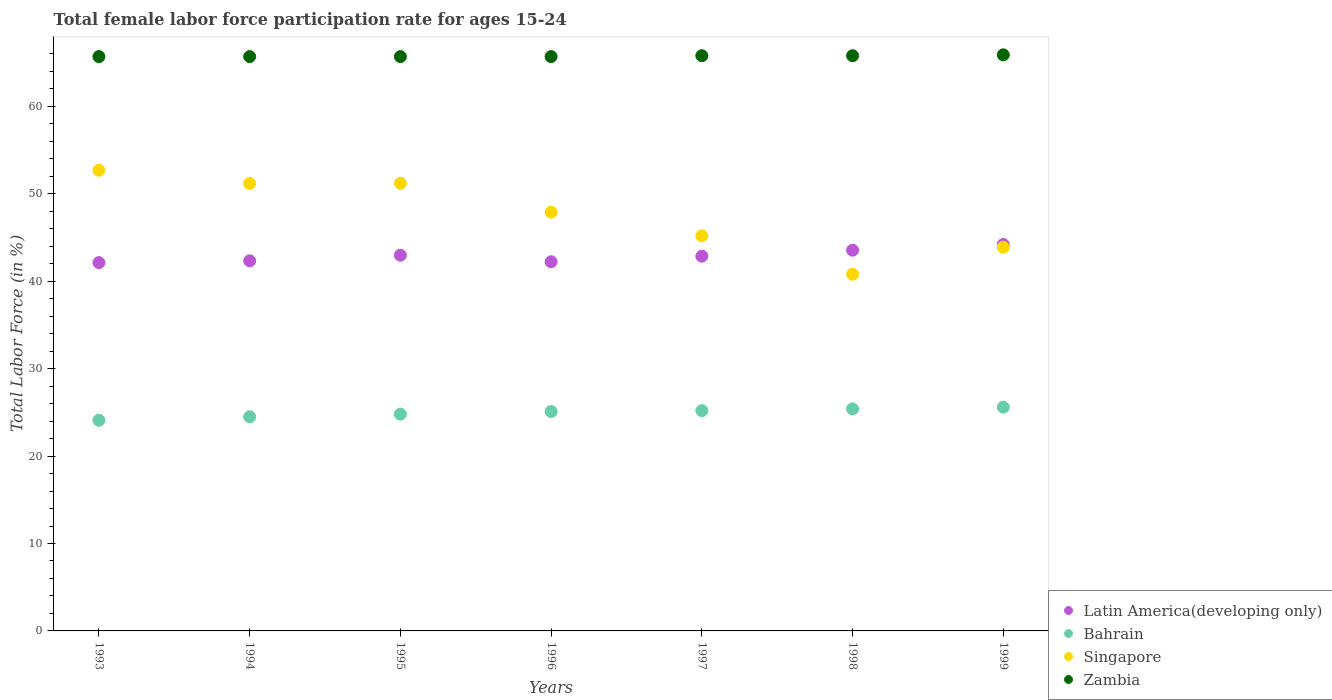What is the female labor force participation rate in Singapore in 1995?
Your answer should be very brief. 51.2. Across all years, what is the maximum female labor force participation rate in Zambia?
Ensure brevity in your answer.  65.9. Across all years, what is the minimum female labor force participation rate in Singapore?
Offer a very short reply. 40.8. What is the total female labor force participation rate in Latin America(developing only) in the graph?
Your response must be concise. 300.31. What is the difference between the female labor force participation rate in Bahrain in 1997 and that in 1999?
Ensure brevity in your answer.  -0.4. What is the difference between the female labor force participation rate in Zambia in 1998 and the female labor force participation rate in Bahrain in 1997?
Provide a short and direct response. 40.6. What is the average female labor force participation rate in Latin America(developing only) per year?
Provide a short and direct response. 42.9. In the year 1999, what is the difference between the female labor force participation rate in Singapore and female labor force participation rate in Latin America(developing only)?
Offer a very short reply. -0.31. In how many years, is the female labor force participation rate in Bahrain greater than 2 %?
Provide a succinct answer. 7. What is the ratio of the female labor force participation rate in Bahrain in 1993 to that in 1999?
Ensure brevity in your answer.  0.94. What is the difference between the highest and the second highest female labor force participation rate in Bahrain?
Your response must be concise. 0.2. What is the difference between the highest and the lowest female labor force participation rate in Latin America(developing only)?
Offer a very short reply. 2.07. Is the sum of the female labor force participation rate in Latin America(developing only) in 1996 and 1997 greater than the maximum female labor force participation rate in Bahrain across all years?
Your answer should be compact. Yes. Does the female labor force participation rate in Singapore monotonically increase over the years?
Your response must be concise. No. How many years are there in the graph?
Give a very brief answer. 7. Does the graph contain grids?
Offer a terse response. No. Where does the legend appear in the graph?
Ensure brevity in your answer.  Bottom right. What is the title of the graph?
Give a very brief answer. Total female labor force participation rate for ages 15-24. What is the label or title of the X-axis?
Give a very brief answer. Years. What is the label or title of the Y-axis?
Offer a terse response. Total Labor Force (in %). What is the Total Labor Force (in %) in Latin America(developing only) in 1993?
Make the answer very short. 42.13. What is the Total Labor Force (in %) in Bahrain in 1993?
Your answer should be very brief. 24.1. What is the Total Labor Force (in %) of Singapore in 1993?
Provide a succinct answer. 52.7. What is the Total Labor Force (in %) of Zambia in 1993?
Provide a short and direct response. 65.7. What is the Total Labor Force (in %) of Latin America(developing only) in 1994?
Your answer should be compact. 42.34. What is the Total Labor Force (in %) in Bahrain in 1994?
Make the answer very short. 24.5. What is the Total Labor Force (in %) in Singapore in 1994?
Offer a very short reply. 51.2. What is the Total Labor Force (in %) in Zambia in 1994?
Ensure brevity in your answer.  65.7. What is the Total Labor Force (in %) of Latin America(developing only) in 1995?
Ensure brevity in your answer.  42.98. What is the Total Labor Force (in %) in Bahrain in 1995?
Keep it short and to the point. 24.8. What is the Total Labor Force (in %) in Singapore in 1995?
Your answer should be compact. 51.2. What is the Total Labor Force (in %) in Zambia in 1995?
Offer a very short reply. 65.7. What is the Total Labor Force (in %) of Latin America(developing only) in 1996?
Make the answer very short. 42.23. What is the Total Labor Force (in %) of Bahrain in 1996?
Provide a succinct answer. 25.1. What is the Total Labor Force (in %) of Singapore in 1996?
Offer a very short reply. 47.9. What is the Total Labor Force (in %) of Zambia in 1996?
Your answer should be compact. 65.7. What is the Total Labor Force (in %) of Latin America(developing only) in 1997?
Ensure brevity in your answer.  42.87. What is the Total Labor Force (in %) in Bahrain in 1997?
Your answer should be very brief. 25.2. What is the Total Labor Force (in %) in Singapore in 1997?
Offer a very short reply. 45.2. What is the Total Labor Force (in %) in Zambia in 1997?
Provide a short and direct response. 65.8. What is the Total Labor Force (in %) of Latin America(developing only) in 1998?
Offer a very short reply. 43.55. What is the Total Labor Force (in %) of Bahrain in 1998?
Give a very brief answer. 25.4. What is the Total Labor Force (in %) in Singapore in 1998?
Make the answer very short. 40.8. What is the Total Labor Force (in %) in Zambia in 1998?
Your answer should be compact. 65.8. What is the Total Labor Force (in %) of Latin America(developing only) in 1999?
Make the answer very short. 44.21. What is the Total Labor Force (in %) in Bahrain in 1999?
Your answer should be compact. 25.6. What is the Total Labor Force (in %) of Singapore in 1999?
Make the answer very short. 43.9. What is the Total Labor Force (in %) in Zambia in 1999?
Your response must be concise. 65.9. Across all years, what is the maximum Total Labor Force (in %) in Latin America(developing only)?
Offer a very short reply. 44.21. Across all years, what is the maximum Total Labor Force (in %) of Bahrain?
Make the answer very short. 25.6. Across all years, what is the maximum Total Labor Force (in %) in Singapore?
Offer a very short reply. 52.7. Across all years, what is the maximum Total Labor Force (in %) in Zambia?
Your response must be concise. 65.9. Across all years, what is the minimum Total Labor Force (in %) in Latin America(developing only)?
Provide a succinct answer. 42.13. Across all years, what is the minimum Total Labor Force (in %) of Bahrain?
Provide a succinct answer. 24.1. Across all years, what is the minimum Total Labor Force (in %) in Singapore?
Your answer should be compact. 40.8. Across all years, what is the minimum Total Labor Force (in %) of Zambia?
Ensure brevity in your answer.  65.7. What is the total Total Labor Force (in %) in Latin America(developing only) in the graph?
Offer a very short reply. 300.31. What is the total Total Labor Force (in %) of Bahrain in the graph?
Your answer should be compact. 174.7. What is the total Total Labor Force (in %) in Singapore in the graph?
Your answer should be very brief. 332.9. What is the total Total Labor Force (in %) of Zambia in the graph?
Ensure brevity in your answer.  460.3. What is the difference between the Total Labor Force (in %) of Latin America(developing only) in 1993 and that in 1994?
Keep it short and to the point. -0.21. What is the difference between the Total Labor Force (in %) in Zambia in 1993 and that in 1994?
Your response must be concise. 0. What is the difference between the Total Labor Force (in %) of Latin America(developing only) in 1993 and that in 1995?
Make the answer very short. -0.85. What is the difference between the Total Labor Force (in %) of Bahrain in 1993 and that in 1995?
Keep it short and to the point. -0.7. What is the difference between the Total Labor Force (in %) of Singapore in 1993 and that in 1995?
Provide a succinct answer. 1.5. What is the difference between the Total Labor Force (in %) of Zambia in 1993 and that in 1995?
Ensure brevity in your answer.  0. What is the difference between the Total Labor Force (in %) of Latin America(developing only) in 1993 and that in 1996?
Offer a terse response. -0.1. What is the difference between the Total Labor Force (in %) in Bahrain in 1993 and that in 1996?
Give a very brief answer. -1. What is the difference between the Total Labor Force (in %) of Latin America(developing only) in 1993 and that in 1997?
Give a very brief answer. -0.74. What is the difference between the Total Labor Force (in %) in Bahrain in 1993 and that in 1997?
Your response must be concise. -1.1. What is the difference between the Total Labor Force (in %) in Zambia in 1993 and that in 1997?
Your response must be concise. -0.1. What is the difference between the Total Labor Force (in %) in Latin America(developing only) in 1993 and that in 1998?
Your answer should be compact. -1.42. What is the difference between the Total Labor Force (in %) of Bahrain in 1993 and that in 1998?
Your answer should be compact. -1.3. What is the difference between the Total Labor Force (in %) of Singapore in 1993 and that in 1998?
Provide a short and direct response. 11.9. What is the difference between the Total Labor Force (in %) of Zambia in 1993 and that in 1998?
Give a very brief answer. -0.1. What is the difference between the Total Labor Force (in %) of Latin America(developing only) in 1993 and that in 1999?
Provide a short and direct response. -2.07. What is the difference between the Total Labor Force (in %) of Latin America(developing only) in 1994 and that in 1995?
Your answer should be compact. -0.64. What is the difference between the Total Labor Force (in %) of Bahrain in 1994 and that in 1995?
Offer a very short reply. -0.3. What is the difference between the Total Labor Force (in %) of Singapore in 1994 and that in 1995?
Offer a terse response. 0. What is the difference between the Total Labor Force (in %) in Zambia in 1994 and that in 1995?
Give a very brief answer. 0. What is the difference between the Total Labor Force (in %) of Latin America(developing only) in 1994 and that in 1996?
Offer a very short reply. 0.11. What is the difference between the Total Labor Force (in %) in Latin America(developing only) in 1994 and that in 1997?
Your answer should be very brief. -0.53. What is the difference between the Total Labor Force (in %) of Bahrain in 1994 and that in 1997?
Your answer should be compact. -0.7. What is the difference between the Total Labor Force (in %) of Latin America(developing only) in 1994 and that in 1998?
Offer a very short reply. -1.21. What is the difference between the Total Labor Force (in %) of Latin America(developing only) in 1994 and that in 1999?
Your response must be concise. -1.87. What is the difference between the Total Labor Force (in %) in Singapore in 1994 and that in 1999?
Offer a terse response. 7.3. What is the difference between the Total Labor Force (in %) of Latin America(developing only) in 1995 and that in 1996?
Your answer should be compact. 0.75. What is the difference between the Total Labor Force (in %) of Singapore in 1995 and that in 1996?
Ensure brevity in your answer.  3.3. What is the difference between the Total Labor Force (in %) in Zambia in 1995 and that in 1996?
Give a very brief answer. 0. What is the difference between the Total Labor Force (in %) of Latin America(developing only) in 1995 and that in 1997?
Offer a terse response. 0.11. What is the difference between the Total Labor Force (in %) of Bahrain in 1995 and that in 1997?
Offer a terse response. -0.4. What is the difference between the Total Labor Force (in %) in Latin America(developing only) in 1995 and that in 1998?
Make the answer very short. -0.57. What is the difference between the Total Labor Force (in %) in Bahrain in 1995 and that in 1998?
Your answer should be very brief. -0.6. What is the difference between the Total Labor Force (in %) of Zambia in 1995 and that in 1998?
Provide a short and direct response. -0.1. What is the difference between the Total Labor Force (in %) in Latin America(developing only) in 1995 and that in 1999?
Make the answer very short. -1.23. What is the difference between the Total Labor Force (in %) in Singapore in 1995 and that in 1999?
Ensure brevity in your answer.  7.3. What is the difference between the Total Labor Force (in %) of Latin America(developing only) in 1996 and that in 1997?
Provide a succinct answer. -0.64. What is the difference between the Total Labor Force (in %) in Singapore in 1996 and that in 1997?
Give a very brief answer. 2.7. What is the difference between the Total Labor Force (in %) in Latin America(developing only) in 1996 and that in 1998?
Offer a terse response. -1.32. What is the difference between the Total Labor Force (in %) of Bahrain in 1996 and that in 1998?
Keep it short and to the point. -0.3. What is the difference between the Total Labor Force (in %) in Singapore in 1996 and that in 1998?
Offer a very short reply. 7.1. What is the difference between the Total Labor Force (in %) of Latin America(developing only) in 1996 and that in 1999?
Your answer should be compact. -1.97. What is the difference between the Total Labor Force (in %) of Latin America(developing only) in 1997 and that in 1998?
Provide a succinct answer. -0.68. What is the difference between the Total Labor Force (in %) in Singapore in 1997 and that in 1998?
Your answer should be very brief. 4.4. What is the difference between the Total Labor Force (in %) of Latin America(developing only) in 1997 and that in 1999?
Provide a succinct answer. -1.34. What is the difference between the Total Labor Force (in %) of Bahrain in 1997 and that in 1999?
Keep it short and to the point. -0.4. What is the difference between the Total Labor Force (in %) of Singapore in 1997 and that in 1999?
Your answer should be very brief. 1.3. What is the difference between the Total Labor Force (in %) of Zambia in 1997 and that in 1999?
Make the answer very short. -0.1. What is the difference between the Total Labor Force (in %) of Latin America(developing only) in 1998 and that in 1999?
Make the answer very short. -0.65. What is the difference between the Total Labor Force (in %) of Latin America(developing only) in 1993 and the Total Labor Force (in %) of Bahrain in 1994?
Offer a terse response. 17.63. What is the difference between the Total Labor Force (in %) of Latin America(developing only) in 1993 and the Total Labor Force (in %) of Singapore in 1994?
Offer a terse response. -9.07. What is the difference between the Total Labor Force (in %) in Latin America(developing only) in 1993 and the Total Labor Force (in %) in Zambia in 1994?
Provide a succinct answer. -23.57. What is the difference between the Total Labor Force (in %) of Bahrain in 1993 and the Total Labor Force (in %) of Singapore in 1994?
Offer a very short reply. -27.1. What is the difference between the Total Labor Force (in %) in Bahrain in 1993 and the Total Labor Force (in %) in Zambia in 1994?
Offer a terse response. -41.6. What is the difference between the Total Labor Force (in %) in Singapore in 1993 and the Total Labor Force (in %) in Zambia in 1994?
Offer a very short reply. -13. What is the difference between the Total Labor Force (in %) in Latin America(developing only) in 1993 and the Total Labor Force (in %) in Bahrain in 1995?
Ensure brevity in your answer.  17.33. What is the difference between the Total Labor Force (in %) in Latin America(developing only) in 1993 and the Total Labor Force (in %) in Singapore in 1995?
Your answer should be very brief. -9.07. What is the difference between the Total Labor Force (in %) in Latin America(developing only) in 1993 and the Total Labor Force (in %) in Zambia in 1995?
Keep it short and to the point. -23.57. What is the difference between the Total Labor Force (in %) of Bahrain in 1993 and the Total Labor Force (in %) of Singapore in 1995?
Your answer should be very brief. -27.1. What is the difference between the Total Labor Force (in %) in Bahrain in 1993 and the Total Labor Force (in %) in Zambia in 1995?
Keep it short and to the point. -41.6. What is the difference between the Total Labor Force (in %) in Singapore in 1993 and the Total Labor Force (in %) in Zambia in 1995?
Your answer should be very brief. -13. What is the difference between the Total Labor Force (in %) of Latin America(developing only) in 1993 and the Total Labor Force (in %) of Bahrain in 1996?
Your answer should be compact. 17.03. What is the difference between the Total Labor Force (in %) in Latin America(developing only) in 1993 and the Total Labor Force (in %) in Singapore in 1996?
Give a very brief answer. -5.77. What is the difference between the Total Labor Force (in %) in Latin America(developing only) in 1993 and the Total Labor Force (in %) in Zambia in 1996?
Offer a terse response. -23.57. What is the difference between the Total Labor Force (in %) of Bahrain in 1993 and the Total Labor Force (in %) of Singapore in 1996?
Make the answer very short. -23.8. What is the difference between the Total Labor Force (in %) of Bahrain in 1993 and the Total Labor Force (in %) of Zambia in 1996?
Keep it short and to the point. -41.6. What is the difference between the Total Labor Force (in %) of Latin America(developing only) in 1993 and the Total Labor Force (in %) of Bahrain in 1997?
Provide a short and direct response. 16.93. What is the difference between the Total Labor Force (in %) of Latin America(developing only) in 1993 and the Total Labor Force (in %) of Singapore in 1997?
Offer a very short reply. -3.07. What is the difference between the Total Labor Force (in %) of Latin America(developing only) in 1993 and the Total Labor Force (in %) of Zambia in 1997?
Your answer should be compact. -23.67. What is the difference between the Total Labor Force (in %) of Bahrain in 1993 and the Total Labor Force (in %) of Singapore in 1997?
Keep it short and to the point. -21.1. What is the difference between the Total Labor Force (in %) of Bahrain in 1993 and the Total Labor Force (in %) of Zambia in 1997?
Provide a succinct answer. -41.7. What is the difference between the Total Labor Force (in %) of Singapore in 1993 and the Total Labor Force (in %) of Zambia in 1997?
Offer a very short reply. -13.1. What is the difference between the Total Labor Force (in %) in Latin America(developing only) in 1993 and the Total Labor Force (in %) in Bahrain in 1998?
Keep it short and to the point. 16.73. What is the difference between the Total Labor Force (in %) of Latin America(developing only) in 1993 and the Total Labor Force (in %) of Singapore in 1998?
Provide a short and direct response. 1.33. What is the difference between the Total Labor Force (in %) in Latin America(developing only) in 1993 and the Total Labor Force (in %) in Zambia in 1998?
Offer a very short reply. -23.67. What is the difference between the Total Labor Force (in %) of Bahrain in 1993 and the Total Labor Force (in %) of Singapore in 1998?
Keep it short and to the point. -16.7. What is the difference between the Total Labor Force (in %) of Bahrain in 1993 and the Total Labor Force (in %) of Zambia in 1998?
Provide a succinct answer. -41.7. What is the difference between the Total Labor Force (in %) in Latin America(developing only) in 1993 and the Total Labor Force (in %) in Bahrain in 1999?
Ensure brevity in your answer.  16.53. What is the difference between the Total Labor Force (in %) in Latin America(developing only) in 1993 and the Total Labor Force (in %) in Singapore in 1999?
Give a very brief answer. -1.77. What is the difference between the Total Labor Force (in %) of Latin America(developing only) in 1993 and the Total Labor Force (in %) of Zambia in 1999?
Provide a short and direct response. -23.77. What is the difference between the Total Labor Force (in %) of Bahrain in 1993 and the Total Labor Force (in %) of Singapore in 1999?
Your answer should be compact. -19.8. What is the difference between the Total Labor Force (in %) in Bahrain in 1993 and the Total Labor Force (in %) in Zambia in 1999?
Your response must be concise. -41.8. What is the difference between the Total Labor Force (in %) of Latin America(developing only) in 1994 and the Total Labor Force (in %) of Bahrain in 1995?
Your answer should be compact. 17.54. What is the difference between the Total Labor Force (in %) of Latin America(developing only) in 1994 and the Total Labor Force (in %) of Singapore in 1995?
Keep it short and to the point. -8.86. What is the difference between the Total Labor Force (in %) of Latin America(developing only) in 1994 and the Total Labor Force (in %) of Zambia in 1995?
Your response must be concise. -23.36. What is the difference between the Total Labor Force (in %) of Bahrain in 1994 and the Total Labor Force (in %) of Singapore in 1995?
Offer a terse response. -26.7. What is the difference between the Total Labor Force (in %) in Bahrain in 1994 and the Total Labor Force (in %) in Zambia in 1995?
Provide a short and direct response. -41.2. What is the difference between the Total Labor Force (in %) in Latin America(developing only) in 1994 and the Total Labor Force (in %) in Bahrain in 1996?
Ensure brevity in your answer.  17.24. What is the difference between the Total Labor Force (in %) of Latin America(developing only) in 1994 and the Total Labor Force (in %) of Singapore in 1996?
Your response must be concise. -5.56. What is the difference between the Total Labor Force (in %) in Latin America(developing only) in 1994 and the Total Labor Force (in %) in Zambia in 1996?
Ensure brevity in your answer.  -23.36. What is the difference between the Total Labor Force (in %) in Bahrain in 1994 and the Total Labor Force (in %) in Singapore in 1996?
Ensure brevity in your answer.  -23.4. What is the difference between the Total Labor Force (in %) in Bahrain in 1994 and the Total Labor Force (in %) in Zambia in 1996?
Give a very brief answer. -41.2. What is the difference between the Total Labor Force (in %) in Latin America(developing only) in 1994 and the Total Labor Force (in %) in Bahrain in 1997?
Ensure brevity in your answer.  17.14. What is the difference between the Total Labor Force (in %) of Latin America(developing only) in 1994 and the Total Labor Force (in %) of Singapore in 1997?
Provide a succinct answer. -2.86. What is the difference between the Total Labor Force (in %) in Latin America(developing only) in 1994 and the Total Labor Force (in %) in Zambia in 1997?
Offer a terse response. -23.46. What is the difference between the Total Labor Force (in %) in Bahrain in 1994 and the Total Labor Force (in %) in Singapore in 1997?
Offer a very short reply. -20.7. What is the difference between the Total Labor Force (in %) of Bahrain in 1994 and the Total Labor Force (in %) of Zambia in 1997?
Your answer should be very brief. -41.3. What is the difference between the Total Labor Force (in %) in Singapore in 1994 and the Total Labor Force (in %) in Zambia in 1997?
Provide a succinct answer. -14.6. What is the difference between the Total Labor Force (in %) of Latin America(developing only) in 1994 and the Total Labor Force (in %) of Bahrain in 1998?
Your response must be concise. 16.94. What is the difference between the Total Labor Force (in %) of Latin America(developing only) in 1994 and the Total Labor Force (in %) of Singapore in 1998?
Ensure brevity in your answer.  1.54. What is the difference between the Total Labor Force (in %) in Latin America(developing only) in 1994 and the Total Labor Force (in %) in Zambia in 1998?
Your answer should be compact. -23.46. What is the difference between the Total Labor Force (in %) in Bahrain in 1994 and the Total Labor Force (in %) in Singapore in 1998?
Keep it short and to the point. -16.3. What is the difference between the Total Labor Force (in %) of Bahrain in 1994 and the Total Labor Force (in %) of Zambia in 1998?
Give a very brief answer. -41.3. What is the difference between the Total Labor Force (in %) in Singapore in 1994 and the Total Labor Force (in %) in Zambia in 1998?
Offer a terse response. -14.6. What is the difference between the Total Labor Force (in %) of Latin America(developing only) in 1994 and the Total Labor Force (in %) of Bahrain in 1999?
Your answer should be very brief. 16.74. What is the difference between the Total Labor Force (in %) of Latin America(developing only) in 1994 and the Total Labor Force (in %) of Singapore in 1999?
Offer a very short reply. -1.56. What is the difference between the Total Labor Force (in %) of Latin America(developing only) in 1994 and the Total Labor Force (in %) of Zambia in 1999?
Offer a very short reply. -23.56. What is the difference between the Total Labor Force (in %) of Bahrain in 1994 and the Total Labor Force (in %) of Singapore in 1999?
Offer a terse response. -19.4. What is the difference between the Total Labor Force (in %) of Bahrain in 1994 and the Total Labor Force (in %) of Zambia in 1999?
Make the answer very short. -41.4. What is the difference between the Total Labor Force (in %) of Singapore in 1994 and the Total Labor Force (in %) of Zambia in 1999?
Provide a succinct answer. -14.7. What is the difference between the Total Labor Force (in %) of Latin America(developing only) in 1995 and the Total Labor Force (in %) of Bahrain in 1996?
Provide a succinct answer. 17.88. What is the difference between the Total Labor Force (in %) of Latin America(developing only) in 1995 and the Total Labor Force (in %) of Singapore in 1996?
Offer a terse response. -4.92. What is the difference between the Total Labor Force (in %) in Latin America(developing only) in 1995 and the Total Labor Force (in %) in Zambia in 1996?
Ensure brevity in your answer.  -22.72. What is the difference between the Total Labor Force (in %) of Bahrain in 1995 and the Total Labor Force (in %) of Singapore in 1996?
Your answer should be compact. -23.1. What is the difference between the Total Labor Force (in %) in Bahrain in 1995 and the Total Labor Force (in %) in Zambia in 1996?
Give a very brief answer. -40.9. What is the difference between the Total Labor Force (in %) of Singapore in 1995 and the Total Labor Force (in %) of Zambia in 1996?
Offer a very short reply. -14.5. What is the difference between the Total Labor Force (in %) in Latin America(developing only) in 1995 and the Total Labor Force (in %) in Bahrain in 1997?
Your response must be concise. 17.78. What is the difference between the Total Labor Force (in %) of Latin America(developing only) in 1995 and the Total Labor Force (in %) of Singapore in 1997?
Keep it short and to the point. -2.22. What is the difference between the Total Labor Force (in %) in Latin America(developing only) in 1995 and the Total Labor Force (in %) in Zambia in 1997?
Your answer should be very brief. -22.82. What is the difference between the Total Labor Force (in %) in Bahrain in 1995 and the Total Labor Force (in %) in Singapore in 1997?
Ensure brevity in your answer.  -20.4. What is the difference between the Total Labor Force (in %) of Bahrain in 1995 and the Total Labor Force (in %) of Zambia in 1997?
Offer a very short reply. -41. What is the difference between the Total Labor Force (in %) in Singapore in 1995 and the Total Labor Force (in %) in Zambia in 1997?
Your answer should be compact. -14.6. What is the difference between the Total Labor Force (in %) in Latin America(developing only) in 1995 and the Total Labor Force (in %) in Bahrain in 1998?
Keep it short and to the point. 17.58. What is the difference between the Total Labor Force (in %) of Latin America(developing only) in 1995 and the Total Labor Force (in %) of Singapore in 1998?
Give a very brief answer. 2.18. What is the difference between the Total Labor Force (in %) of Latin America(developing only) in 1995 and the Total Labor Force (in %) of Zambia in 1998?
Make the answer very short. -22.82. What is the difference between the Total Labor Force (in %) of Bahrain in 1995 and the Total Labor Force (in %) of Singapore in 1998?
Provide a succinct answer. -16. What is the difference between the Total Labor Force (in %) in Bahrain in 1995 and the Total Labor Force (in %) in Zambia in 1998?
Give a very brief answer. -41. What is the difference between the Total Labor Force (in %) in Singapore in 1995 and the Total Labor Force (in %) in Zambia in 1998?
Your answer should be very brief. -14.6. What is the difference between the Total Labor Force (in %) of Latin America(developing only) in 1995 and the Total Labor Force (in %) of Bahrain in 1999?
Keep it short and to the point. 17.38. What is the difference between the Total Labor Force (in %) in Latin America(developing only) in 1995 and the Total Labor Force (in %) in Singapore in 1999?
Offer a terse response. -0.92. What is the difference between the Total Labor Force (in %) in Latin America(developing only) in 1995 and the Total Labor Force (in %) in Zambia in 1999?
Provide a succinct answer. -22.92. What is the difference between the Total Labor Force (in %) in Bahrain in 1995 and the Total Labor Force (in %) in Singapore in 1999?
Give a very brief answer. -19.1. What is the difference between the Total Labor Force (in %) of Bahrain in 1995 and the Total Labor Force (in %) of Zambia in 1999?
Your answer should be compact. -41.1. What is the difference between the Total Labor Force (in %) of Singapore in 1995 and the Total Labor Force (in %) of Zambia in 1999?
Ensure brevity in your answer.  -14.7. What is the difference between the Total Labor Force (in %) of Latin America(developing only) in 1996 and the Total Labor Force (in %) of Bahrain in 1997?
Keep it short and to the point. 17.03. What is the difference between the Total Labor Force (in %) of Latin America(developing only) in 1996 and the Total Labor Force (in %) of Singapore in 1997?
Provide a succinct answer. -2.97. What is the difference between the Total Labor Force (in %) in Latin America(developing only) in 1996 and the Total Labor Force (in %) in Zambia in 1997?
Provide a succinct answer. -23.57. What is the difference between the Total Labor Force (in %) in Bahrain in 1996 and the Total Labor Force (in %) in Singapore in 1997?
Provide a short and direct response. -20.1. What is the difference between the Total Labor Force (in %) of Bahrain in 1996 and the Total Labor Force (in %) of Zambia in 1997?
Your answer should be very brief. -40.7. What is the difference between the Total Labor Force (in %) in Singapore in 1996 and the Total Labor Force (in %) in Zambia in 1997?
Ensure brevity in your answer.  -17.9. What is the difference between the Total Labor Force (in %) of Latin America(developing only) in 1996 and the Total Labor Force (in %) of Bahrain in 1998?
Offer a terse response. 16.83. What is the difference between the Total Labor Force (in %) of Latin America(developing only) in 1996 and the Total Labor Force (in %) of Singapore in 1998?
Provide a succinct answer. 1.43. What is the difference between the Total Labor Force (in %) in Latin America(developing only) in 1996 and the Total Labor Force (in %) in Zambia in 1998?
Make the answer very short. -23.57. What is the difference between the Total Labor Force (in %) of Bahrain in 1996 and the Total Labor Force (in %) of Singapore in 1998?
Your response must be concise. -15.7. What is the difference between the Total Labor Force (in %) of Bahrain in 1996 and the Total Labor Force (in %) of Zambia in 1998?
Keep it short and to the point. -40.7. What is the difference between the Total Labor Force (in %) in Singapore in 1996 and the Total Labor Force (in %) in Zambia in 1998?
Provide a succinct answer. -17.9. What is the difference between the Total Labor Force (in %) of Latin America(developing only) in 1996 and the Total Labor Force (in %) of Bahrain in 1999?
Ensure brevity in your answer.  16.63. What is the difference between the Total Labor Force (in %) of Latin America(developing only) in 1996 and the Total Labor Force (in %) of Singapore in 1999?
Offer a terse response. -1.67. What is the difference between the Total Labor Force (in %) of Latin America(developing only) in 1996 and the Total Labor Force (in %) of Zambia in 1999?
Offer a terse response. -23.67. What is the difference between the Total Labor Force (in %) in Bahrain in 1996 and the Total Labor Force (in %) in Singapore in 1999?
Provide a short and direct response. -18.8. What is the difference between the Total Labor Force (in %) in Bahrain in 1996 and the Total Labor Force (in %) in Zambia in 1999?
Give a very brief answer. -40.8. What is the difference between the Total Labor Force (in %) of Latin America(developing only) in 1997 and the Total Labor Force (in %) of Bahrain in 1998?
Provide a succinct answer. 17.47. What is the difference between the Total Labor Force (in %) in Latin America(developing only) in 1997 and the Total Labor Force (in %) in Singapore in 1998?
Your answer should be very brief. 2.07. What is the difference between the Total Labor Force (in %) of Latin America(developing only) in 1997 and the Total Labor Force (in %) of Zambia in 1998?
Make the answer very short. -22.93. What is the difference between the Total Labor Force (in %) of Bahrain in 1997 and the Total Labor Force (in %) of Singapore in 1998?
Your answer should be compact. -15.6. What is the difference between the Total Labor Force (in %) in Bahrain in 1997 and the Total Labor Force (in %) in Zambia in 1998?
Offer a terse response. -40.6. What is the difference between the Total Labor Force (in %) of Singapore in 1997 and the Total Labor Force (in %) of Zambia in 1998?
Offer a very short reply. -20.6. What is the difference between the Total Labor Force (in %) of Latin America(developing only) in 1997 and the Total Labor Force (in %) of Bahrain in 1999?
Offer a very short reply. 17.27. What is the difference between the Total Labor Force (in %) in Latin America(developing only) in 1997 and the Total Labor Force (in %) in Singapore in 1999?
Your response must be concise. -1.03. What is the difference between the Total Labor Force (in %) in Latin America(developing only) in 1997 and the Total Labor Force (in %) in Zambia in 1999?
Offer a terse response. -23.03. What is the difference between the Total Labor Force (in %) in Bahrain in 1997 and the Total Labor Force (in %) in Singapore in 1999?
Make the answer very short. -18.7. What is the difference between the Total Labor Force (in %) in Bahrain in 1997 and the Total Labor Force (in %) in Zambia in 1999?
Make the answer very short. -40.7. What is the difference between the Total Labor Force (in %) of Singapore in 1997 and the Total Labor Force (in %) of Zambia in 1999?
Offer a very short reply. -20.7. What is the difference between the Total Labor Force (in %) in Latin America(developing only) in 1998 and the Total Labor Force (in %) in Bahrain in 1999?
Keep it short and to the point. 17.95. What is the difference between the Total Labor Force (in %) in Latin America(developing only) in 1998 and the Total Labor Force (in %) in Singapore in 1999?
Your answer should be compact. -0.35. What is the difference between the Total Labor Force (in %) in Latin America(developing only) in 1998 and the Total Labor Force (in %) in Zambia in 1999?
Your answer should be compact. -22.35. What is the difference between the Total Labor Force (in %) in Bahrain in 1998 and the Total Labor Force (in %) in Singapore in 1999?
Offer a terse response. -18.5. What is the difference between the Total Labor Force (in %) in Bahrain in 1998 and the Total Labor Force (in %) in Zambia in 1999?
Ensure brevity in your answer.  -40.5. What is the difference between the Total Labor Force (in %) in Singapore in 1998 and the Total Labor Force (in %) in Zambia in 1999?
Provide a short and direct response. -25.1. What is the average Total Labor Force (in %) of Latin America(developing only) per year?
Your answer should be compact. 42.9. What is the average Total Labor Force (in %) in Bahrain per year?
Make the answer very short. 24.96. What is the average Total Labor Force (in %) in Singapore per year?
Your answer should be compact. 47.56. What is the average Total Labor Force (in %) of Zambia per year?
Provide a short and direct response. 65.76. In the year 1993, what is the difference between the Total Labor Force (in %) of Latin America(developing only) and Total Labor Force (in %) of Bahrain?
Keep it short and to the point. 18.03. In the year 1993, what is the difference between the Total Labor Force (in %) of Latin America(developing only) and Total Labor Force (in %) of Singapore?
Offer a very short reply. -10.57. In the year 1993, what is the difference between the Total Labor Force (in %) in Latin America(developing only) and Total Labor Force (in %) in Zambia?
Give a very brief answer. -23.57. In the year 1993, what is the difference between the Total Labor Force (in %) in Bahrain and Total Labor Force (in %) in Singapore?
Provide a succinct answer. -28.6. In the year 1993, what is the difference between the Total Labor Force (in %) of Bahrain and Total Labor Force (in %) of Zambia?
Keep it short and to the point. -41.6. In the year 1993, what is the difference between the Total Labor Force (in %) of Singapore and Total Labor Force (in %) of Zambia?
Your response must be concise. -13. In the year 1994, what is the difference between the Total Labor Force (in %) of Latin America(developing only) and Total Labor Force (in %) of Bahrain?
Offer a very short reply. 17.84. In the year 1994, what is the difference between the Total Labor Force (in %) in Latin America(developing only) and Total Labor Force (in %) in Singapore?
Your response must be concise. -8.86. In the year 1994, what is the difference between the Total Labor Force (in %) in Latin America(developing only) and Total Labor Force (in %) in Zambia?
Make the answer very short. -23.36. In the year 1994, what is the difference between the Total Labor Force (in %) of Bahrain and Total Labor Force (in %) of Singapore?
Your answer should be compact. -26.7. In the year 1994, what is the difference between the Total Labor Force (in %) of Bahrain and Total Labor Force (in %) of Zambia?
Ensure brevity in your answer.  -41.2. In the year 1995, what is the difference between the Total Labor Force (in %) in Latin America(developing only) and Total Labor Force (in %) in Bahrain?
Make the answer very short. 18.18. In the year 1995, what is the difference between the Total Labor Force (in %) in Latin America(developing only) and Total Labor Force (in %) in Singapore?
Your response must be concise. -8.22. In the year 1995, what is the difference between the Total Labor Force (in %) of Latin America(developing only) and Total Labor Force (in %) of Zambia?
Your answer should be compact. -22.72. In the year 1995, what is the difference between the Total Labor Force (in %) of Bahrain and Total Labor Force (in %) of Singapore?
Ensure brevity in your answer.  -26.4. In the year 1995, what is the difference between the Total Labor Force (in %) in Bahrain and Total Labor Force (in %) in Zambia?
Offer a terse response. -40.9. In the year 1996, what is the difference between the Total Labor Force (in %) in Latin America(developing only) and Total Labor Force (in %) in Bahrain?
Your response must be concise. 17.13. In the year 1996, what is the difference between the Total Labor Force (in %) of Latin America(developing only) and Total Labor Force (in %) of Singapore?
Offer a very short reply. -5.67. In the year 1996, what is the difference between the Total Labor Force (in %) of Latin America(developing only) and Total Labor Force (in %) of Zambia?
Provide a short and direct response. -23.47. In the year 1996, what is the difference between the Total Labor Force (in %) of Bahrain and Total Labor Force (in %) of Singapore?
Make the answer very short. -22.8. In the year 1996, what is the difference between the Total Labor Force (in %) in Bahrain and Total Labor Force (in %) in Zambia?
Offer a terse response. -40.6. In the year 1996, what is the difference between the Total Labor Force (in %) of Singapore and Total Labor Force (in %) of Zambia?
Make the answer very short. -17.8. In the year 1997, what is the difference between the Total Labor Force (in %) in Latin America(developing only) and Total Labor Force (in %) in Bahrain?
Offer a very short reply. 17.67. In the year 1997, what is the difference between the Total Labor Force (in %) of Latin America(developing only) and Total Labor Force (in %) of Singapore?
Ensure brevity in your answer.  -2.33. In the year 1997, what is the difference between the Total Labor Force (in %) of Latin America(developing only) and Total Labor Force (in %) of Zambia?
Make the answer very short. -22.93. In the year 1997, what is the difference between the Total Labor Force (in %) of Bahrain and Total Labor Force (in %) of Singapore?
Keep it short and to the point. -20. In the year 1997, what is the difference between the Total Labor Force (in %) in Bahrain and Total Labor Force (in %) in Zambia?
Offer a terse response. -40.6. In the year 1997, what is the difference between the Total Labor Force (in %) of Singapore and Total Labor Force (in %) of Zambia?
Your answer should be compact. -20.6. In the year 1998, what is the difference between the Total Labor Force (in %) in Latin America(developing only) and Total Labor Force (in %) in Bahrain?
Keep it short and to the point. 18.15. In the year 1998, what is the difference between the Total Labor Force (in %) in Latin America(developing only) and Total Labor Force (in %) in Singapore?
Your answer should be very brief. 2.75. In the year 1998, what is the difference between the Total Labor Force (in %) of Latin America(developing only) and Total Labor Force (in %) of Zambia?
Offer a terse response. -22.25. In the year 1998, what is the difference between the Total Labor Force (in %) in Bahrain and Total Labor Force (in %) in Singapore?
Provide a short and direct response. -15.4. In the year 1998, what is the difference between the Total Labor Force (in %) of Bahrain and Total Labor Force (in %) of Zambia?
Offer a very short reply. -40.4. In the year 1998, what is the difference between the Total Labor Force (in %) in Singapore and Total Labor Force (in %) in Zambia?
Your response must be concise. -25. In the year 1999, what is the difference between the Total Labor Force (in %) of Latin America(developing only) and Total Labor Force (in %) of Bahrain?
Make the answer very short. 18.61. In the year 1999, what is the difference between the Total Labor Force (in %) of Latin America(developing only) and Total Labor Force (in %) of Singapore?
Provide a succinct answer. 0.31. In the year 1999, what is the difference between the Total Labor Force (in %) in Latin America(developing only) and Total Labor Force (in %) in Zambia?
Make the answer very short. -21.69. In the year 1999, what is the difference between the Total Labor Force (in %) of Bahrain and Total Labor Force (in %) of Singapore?
Ensure brevity in your answer.  -18.3. In the year 1999, what is the difference between the Total Labor Force (in %) of Bahrain and Total Labor Force (in %) of Zambia?
Your response must be concise. -40.3. What is the ratio of the Total Labor Force (in %) of Bahrain in 1993 to that in 1994?
Offer a terse response. 0.98. What is the ratio of the Total Labor Force (in %) of Singapore in 1993 to that in 1994?
Provide a succinct answer. 1.03. What is the ratio of the Total Labor Force (in %) in Zambia in 1993 to that in 1994?
Offer a very short reply. 1. What is the ratio of the Total Labor Force (in %) in Latin America(developing only) in 1993 to that in 1995?
Keep it short and to the point. 0.98. What is the ratio of the Total Labor Force (in %) of Bahrain in 1993 to that in 1995?
Offer a very short reply. 0.97. What is the ratio of the Total Labor Force (in %) in Singapore in 1993 to that in 1995?
Keep it short and to the point. 1.03. What is the ratio of the Total Labor Force (in %) in Zambia in 1993 to that in 1995?
Your answer should be compact. 1. What is the ratio of the Total Labor Force (in %) in Latin America(developing only) in 1993 to that in 1996?
Give a very brief answer. 1. What is the ratio of the Total Labor Force (in %) in Bahrain in 1993 to that in 1996?
Your answer should be very brief. 0.96. What is the ratio of the Total Labor Force (in %) in Singapore in 1993 to that in 1996?
Give a very brief answer. 1.1. What is the ratio of the Total Labor Force (in %) in Zambia in 1993 to that in 1996?
Make the answer very short. 1. What is the ratio of the Total Labor Force (in %) in Latin America(developing only) in 1993 to that in 1997?
Make the answer very short. 0.98. What is the ratio of the Total Labor Force (in %) of Bahrain in 1993 to that in 1997?
Your answer should be very brief. 0.96. What is the ratio of the Total Labor Force (in %) in Singapore in 1993 to that in 1997?
Give a very brief answer. 1.17. What is the ratio of the Total Labor Force (in %) of Latin America(developing only) in 1993 to that in 1998?
Provide a succinct answer. 0.97. What is the ratio of the Total Labor Force (in %) of Bahrain in 1993 to that in 1998?
Your answer should be compact. 0.95. What is the ratio of the Total Labor Force (in %) in Singapore in 1993 to that in 1998?
Your answer should be compact. 1.29. What is the ratio of the Total Labor Force (in %) of Zambia in 1993 to that in 1998?
Your response must be concise. 1. What is the ratio of the Total Labor Force (in %) in Latin America(developing only) in 1993 to that in 1999?
Make the answer very short. 0.95. What is the ratio of the Total Labor Force (in %) of Bahrain in 1993 to that in 1999?
Keep it short and to the point. 0.94. What is the ratio of the Total Labor Force (in %) of Singapore in 1993 to that in 1999?
Your response must be concise. 1.2. What is the ratio of the Total Labor Force (in %) in Zambia in 1993 to that in 1999?
Give a very brief answer. 1. What is the ratio of the Total Labor Force (in %) in Latin America(developing only) in 1994 to that in 1995?
Ensure brevity in your answer.  0.99. What is the ratio of the Total Labor Force (in %) in Bahrain in 1994 to that in 1995?
Your response must be concise. 0.99. What is the ratio of the Total Labor Force (in %) of Bahrain in 1994 to that in 1996?
Your answer should be compact. 0.98. What is the ratio of the Total Labor Force (in %) in Singapore in 1994 to that in 1996?
Provide a short and direct response. 1.07. What is the ratio of the Total Labor Force (in %) of Latin America(developing only) in 1994 to that in 1997?
Provide a short and direct response. 0.99. What is the ratio of the Total Labor Force (in %) in Bahrain in 1994 to that in 1997?
Provide a short and direct response. 0.97. What is the ratio of the Total Labor Force (in %) in Singapore in 1994 to that in 1997?
Offer a very short reply. 1.13. What is the ratio of the Total Labor Force (in %) in Latin America(developing only) in 1994 to that in 1998?
Offer a terse response. 0.97. What is the ratio of the Total Labor Force (in %) of Bahrain in 1994 to that in 1998?
Provide a short and direct response. 0.96. What is the ratio of the Total Labor Force (in %) of Singapore in 1994 to that in 1998?
Provide a succinct answer. 1.25. What is the ratio of the Total Labor Force (in %) in Latin America(developing only) in 1994 to that in 1999?
Your answer should be very brief. 0.96. What is the ratio of the Total Labor Force (in %) of Bahrain in 1994 to that in 1999?
Provide a short and direct response. 0.96. What is the ratio of the Total Labor Force (in %) in Singapore in 1994 to that in 1999?
Your response must be concise. 1.17. What is the ratio of the Total Labor Force (in %) of Zambia in 1994 to that in 1999?
Offer a very short reply. 1. What is the ratio of the Total Labor Force (in %) in Latin America(developing only) in 1995 to that in 1996?
Your answer should be very brief. 1.02. What is the ratio of the Total Labor Force (in %) of Bahrain in 1995 to that in 1996?
Provide a short and direct response. 0.99. What is the ratio of the Total Labor Force (in %) of Singapore in 1995 to that in 1996?
Ensure brevity in your answer.  1.07. What is the ratio of the Total Labor Force (in %) in Zambia in 1995 to that in 1996?
Your answer should be compact. 1. What is the ratio of the Total Labor Force (in %) of Bahrain in 1995 to that in 1997?
Offer a terse response. 0.98. What is the ratio of the Total Labor Force (in %) of Singapore in 1995 to that in 1997?
Give a very brief answer. 1.13. What is the ratio of the Total Labor Force (in %) in Bahrain in 1995 to that in 1998?
Your answer should be compact. 0.98. What is the ratio of the Total Labor Force (in %) of Singapore in 1995 to that in 1998?
Your answer should be compact. 1.25. What is the ratio of the Total Labor Force (in %) of Zambia in 1995 to that in 1998?
Your answer should be very brief. 1. What is the ratio of the Total Labor Force (in %) of Latin America(developing only) in 1995 to that in 1999?
Provide a succinct answer. 0.97. What is the ratio of the Total Labor Force (in %) of Bahrain in 1995 to that in 1999?
Your response must be concise. 0.97. What is the ratio of the Total Labor Force (in %) of Singapore in 1995 to that in 1999?
Keep it short and to the point. 1.17. What is the ratio of the Total Labor Force (in %) of Zambia in 1995 to that in 1999?
Ensure brevity in your answer.  1. What is the ratio of the Total Labor Force (in %) of Latin America(developing only) in 1996 to that in 1997?
Offer a terse response. 0.99. What is the ratio of the Total Labor Force (in %) in Singapore in 1996 to that in 1997?
Keep it short and to the point. 1.06. What is the ratio of the Total Labor Force (in %) of Zambia in 1996 to that in 1997?
Your answer should be compact. 1. What is the ratio of the Total Labor Force (in %) in Latin America(developing only) in 1996 to that in 1998?
Your answer should be compact. 0.97. What is the ratio of the Total Labor Force (in %) in Singapore in 1996 to that in 1998?
Offer a terse response. 1.17. What is the ratio of the Total Labor Force (in %) in Latin America(developing only) in 1996 to that in 1999?
Offer a terse response. 0.96. What is the ratio of the Total Labor Force (in %) of Bahrain in 1996 to that in 1999?
Your response must be concise. 0.98. What is the ratio of the Total Labor Force (in %) in Singapore in 1996 to that in 1999?
Provide a short and direct response. 1.09. What is the ratio of the Total Labor Force (in %) of Latin America(developing only) in 1997 to that in 1998?
Give a very brief answer. 0.98. What is the ratio of the Total Labor Force (in %) in Singapore in 1997 to that in 1998?
Your response must be concise. 1.11. What is the ratio of the Total Labor Force (in %) in Zambia in 1997 to that in 1998?
Offer a very short reply. 1. What is the ratio of the Total Labor Force (in %) in Latin America(developing only) in 1997 to that in 1999?
Offer a terse response. 0.97. What is the ratio of the Total Labor Force (in %) in Bahrain in 1997 to that in 1999?
Ensure brevity in your answer.  0.98. What is the ratio of the Total Labor Force (in %) in Singapore in 1997 to that in 1999?
Make the answer very short. 1.03. What is the ratio of the Total Labor Force (in %) of Latin America(developing only) in 1998 to that in 1999?
Your answer should be very brief. 0.99. What is the ratio of the Total Labor Force (in %) in Singapore in 1998 to that in 1999?
Make the answer very short. 0.93. What is the ratio of the Total Labor Force (in %) of Zambia in 1998 to that in 1999?
Provide a succinct answer. 1. What is the difference between the highest and the second highest Total Labor Force (in %) in Latin America(developing only)?
Offer a very short reply. 0.65. What is the difference between the highest and the second highest Total Labor Force (in %) in Singapore?
Make the answer very short. 1.5. What is the difference between the highest and the lowest Total Labor Force (in %) of Latin America(developing only)?
Ensure brevity in your answer.  2.07. What is the difference between the highest and the lowest Total Labor Force (in %) in Zambia?
Your answer should be compact. 0.2. 